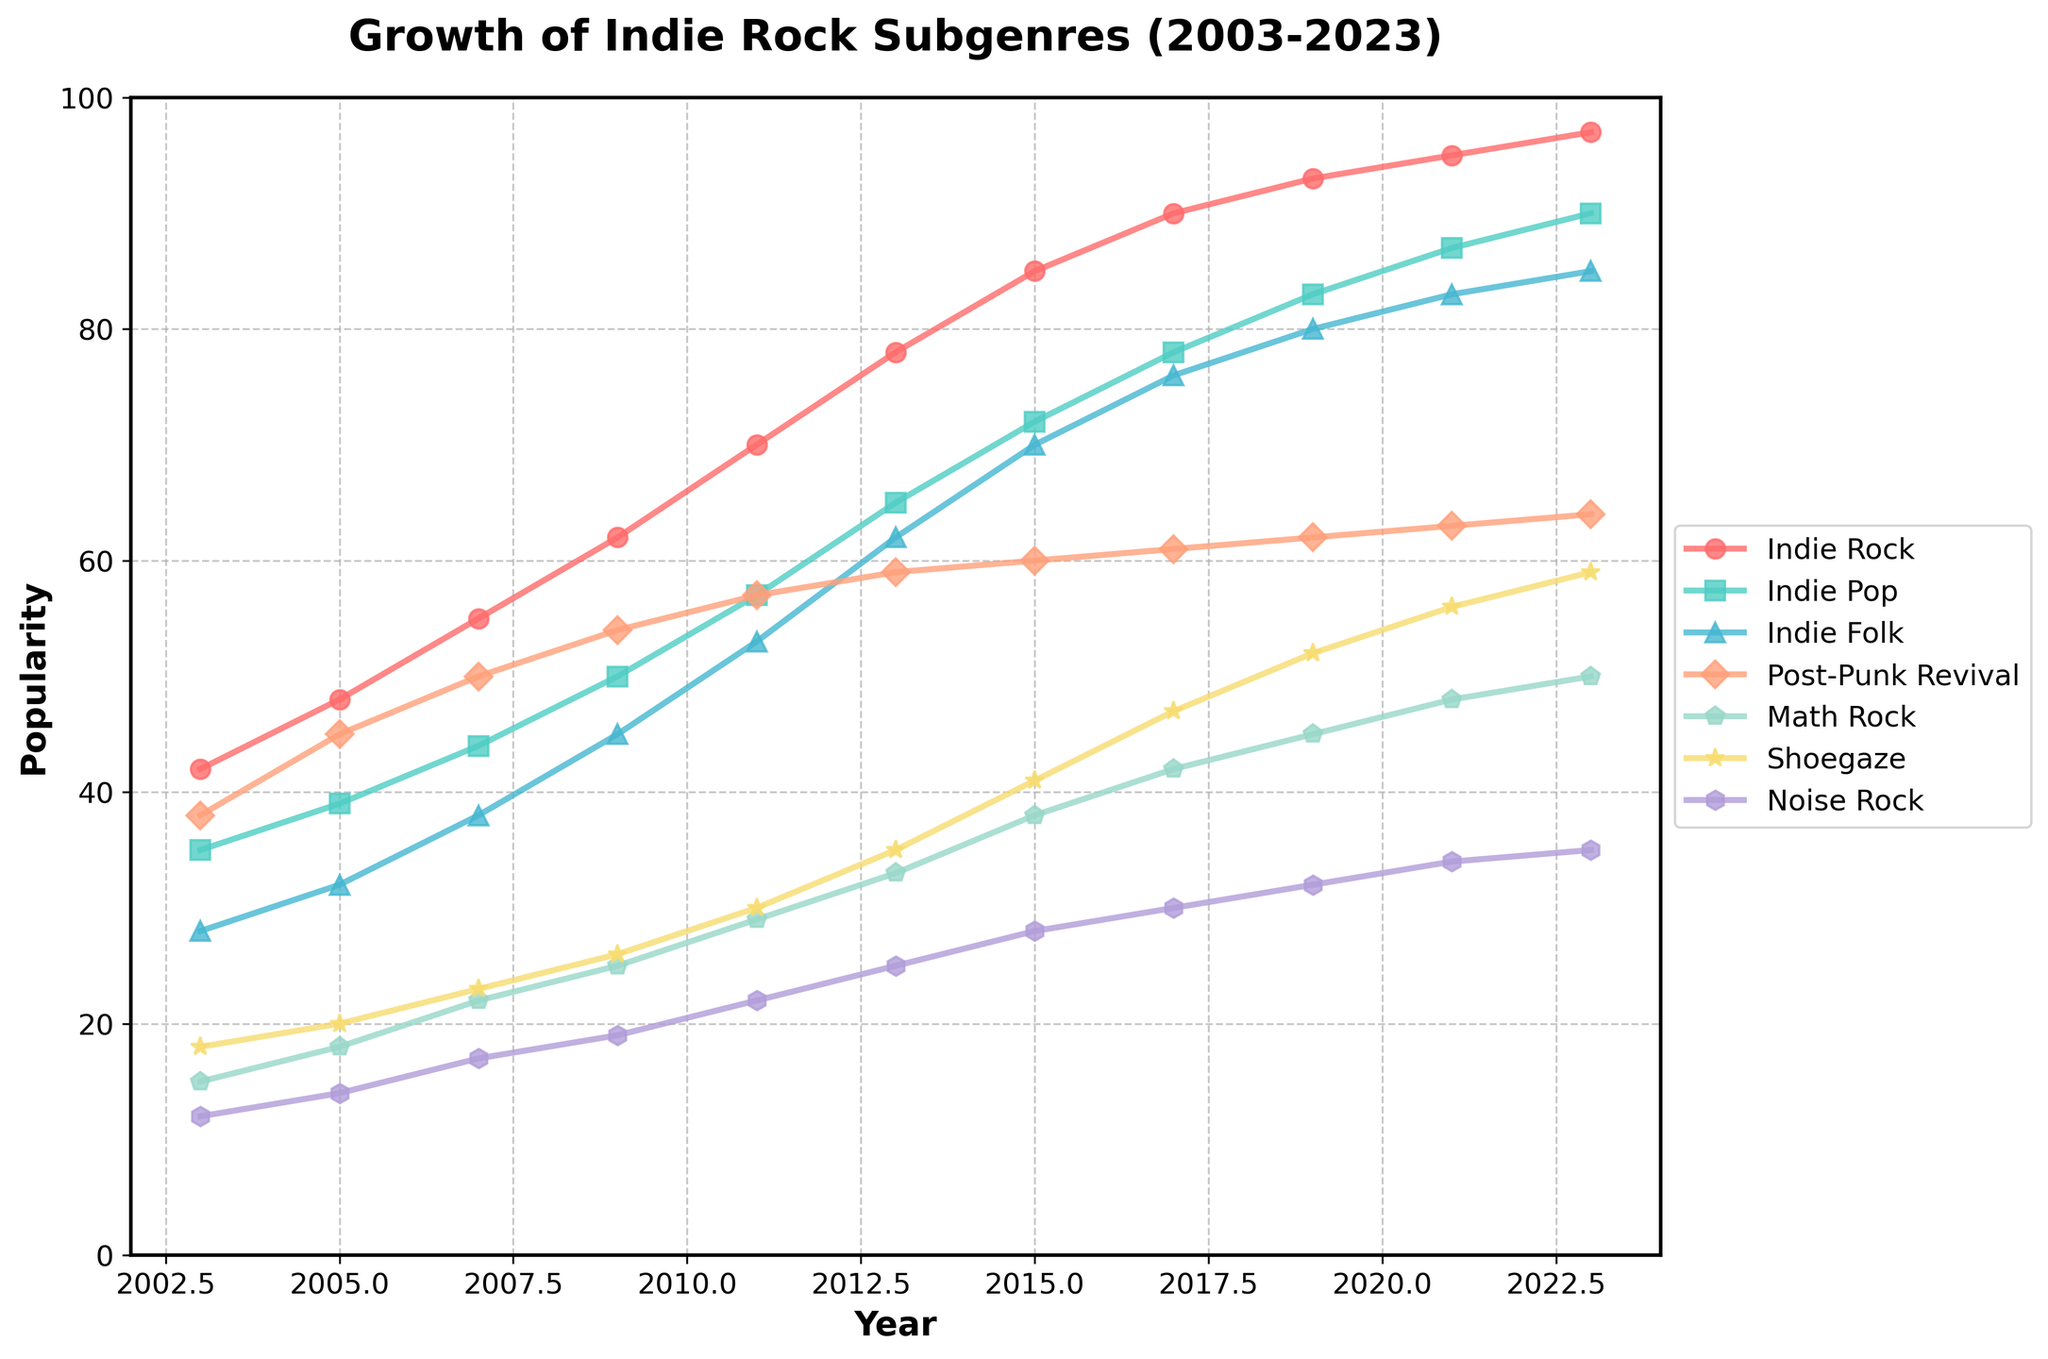Which subgenre showed the most significant increase in popularity between 2003 and 2023? Calculate the difference in popularity for each subgenre between 2003 and 2023. Indie Rock shows an increase from 42 to 97, which is a 55-point increase, the highest among all subgenres.
Answer: Indie Rock Which year did Indie Pop first surpass a popularity score of 80? Examine the data points for Indie Pop each year and identify when it first crossed the 80 mark. Indie Pop reaches 83 in 2019.
Answer: 2019 By how much did the popularity of Math Rock grow between 2011 and 2023? Subtract the popularity score of Math Rock in 2011 (29) from that in 2023 (50). The growth is 21 points.
Answer: 21 Which subgenre had the least popularity in 2023, and what was its score? Analyze the final data points for each subgenre in 2023. Noise Rock, with a score of 35, has the least popularity.
Answer: Noise Rock, 35 Between which consecutive years did Shoegaze see its highest growth rate? Compare the differences in Shoegaze’s popularity for all consecutive years and identify the maximum. The highest growth occurred between 2015 and 2017, increasing from 41 to 47 (6 points).
Answer: 2015-2017 Which two subgenres had the closest popularity scores in 2007, and what were the scores? Review the 2007 data and find the closest scores: Indie Pop (44) and Indie Folk (38), with a difference of 6.
Answer: Indie Pop (44) and Indie Folk (38) On average, how much did the popularity of Post-Punk Revival increase per year from 2003 to 2023? Calculate the total increase in Post-Punk Revival's popularity from 2003 (38) to 2023 (64), which is 26 points, then divide by the number of years (20). 26/20 = 1.3 points per year.
Answer: 1.3 points per year Which subgenre consistently showed an increase in popularity every year mentioned in the data? Check each year for each subgenre to confirm that its popularity increases every time. Indie Rock shows consistent growth.
Answer: Indie Rock By how much did the total popularity of all subgenres increase from 2003 to 2023? Sum the popularity scores for all subgenres for both years, then find the difference: (42+35+28+38+15+18+12) for 2003 = 188; (97+90+85+64+50+59+35) for 2023 = 480; 480 - 188 = 292.
Answer: 292 Which subgenres have shown continuous growth over the past two decades, without any drops in popularity from one year to the next? Examine each subgenre's yearly data to ensure there are no decreases. Indie Rock, Indie Pop, and Post-Punk Revival show continuous growth.
Answer: Indie Rock, Indie Pop, Post-Punk Revival 